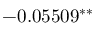Convert formula to latex. <formula><loc_0><loc_0><loc_500><loc_500>- 0 . 0 5 5 0 9 ^ { \ast \ast }</formula> 